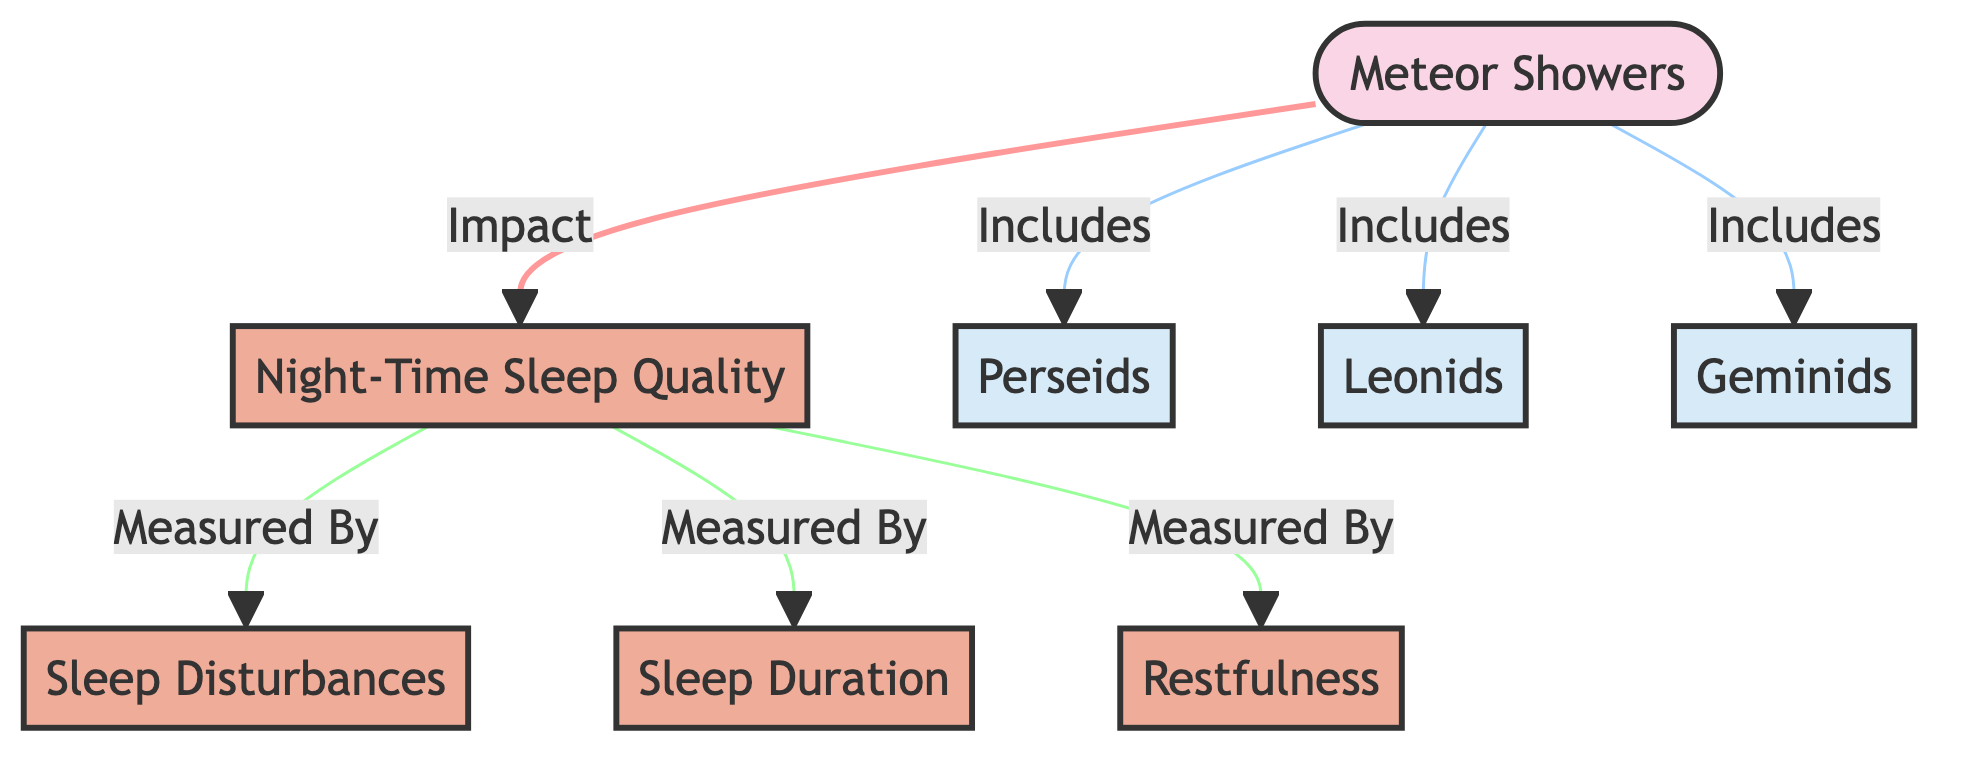what are the specific meteor showers included in the diagram? The diagram lists three specific meteor showers: Perseids, Leonids, and Geminids, which are categorized under Meteor Showers.
Answer: Perseids, Leonids, Geminids how many measurements are associated with Night-Time Sleep Quality? The diagram indicates three measurements related to Night-Time Sleep Quality: Sleep Disturbances, Sleep Duration, and Restfulness.
Answer: Three what do Meteor Showers impact according to the diagram? The arrow connecting Meteor Showers to Night-Time Sleep Quality indicates that they impact this measurement.
Answer: Night-Time Sleep Quality what type of events are Perseids classified as in the diagram? Perseids is labeled as a subEvent under the category of Meteor Showers, indicating its classification.
Answer: SubEvent which measurement is directly linked to Sleep Disturbances? The diagram shows a direct link from Sleep Quality to Sleep Disturbances, meaning they are connected in terms of measurement.
Answer: Sleep Quality if Meteor Showers are present, what is the likely effect on sleep patterns? The diagram suggests a connection indicating that the presence of Meteor Showers could lead to disruptions in sleep patterns, specifically impacting Night-Time Sleep Quality.
Answer: Disruptions how is Sleep Quality measured in the diagram? The diagram outlines three distinct ways to measure Sleep Quality: Sleep Disturbances, Sleep Duration, and Restfulness, showing measurement relationships.
Answer: By Sleep Disturbances, Sleep Duration, Restfulness what is the relationship between Meteor Showers and Sleep Quality in the diagram? The diagram illustrates that there is a direct impact of Meteor Showers on Night-Time Sleep Quality, suggesting a causal relationship.
Answer: Impact what type of diagram is being used to depict the relationships and effects in this study? This diagram is categorized as a flowchart, depicting the relationships and pathways between events and measurements in a structured format.
Answer: Flowchart 